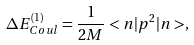<formula> <loc_0><loc_0><loc_500><loc_500>\Delta E ^ { ( 1 ) } _ { C o u l } = \frac { 1 } { 2 M } < { n } | { p } ^ { 2 } | n > ,</formula> 